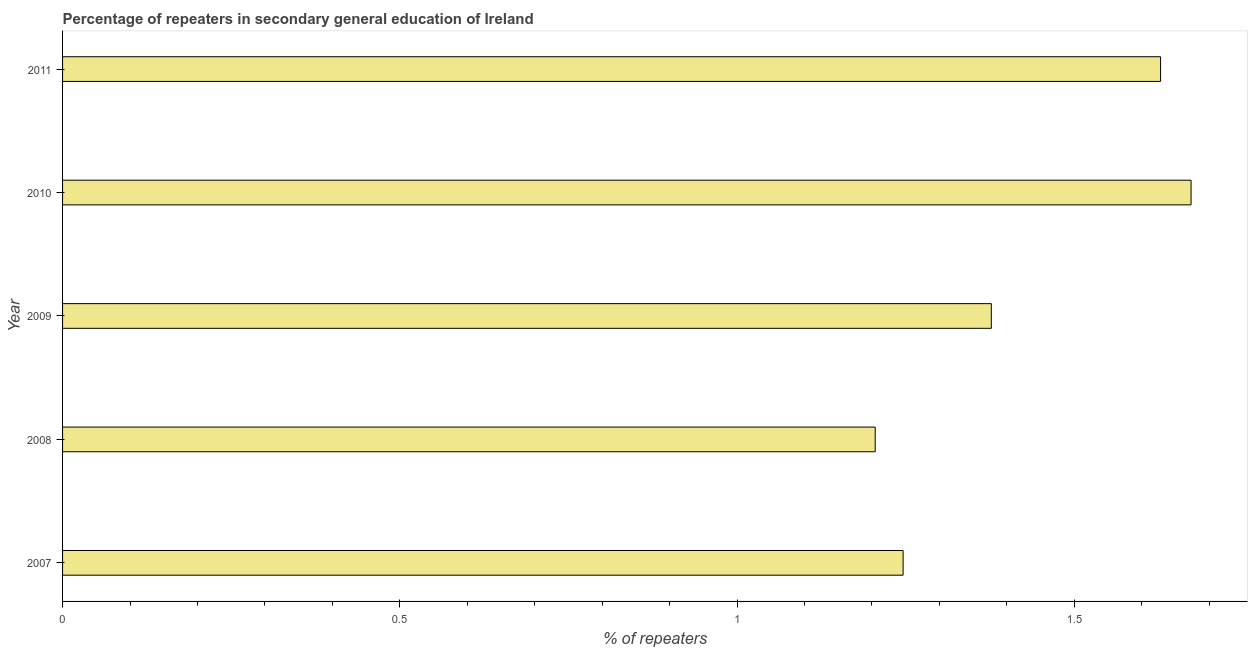What is the title of the graph?
Your answer should be compact. Percentage of repeaters in secondary general education of Ireland. What is the label or title of the X-axis?
Keep it short and to the point. % of repeaters. What is the label or title of the Y-axis?
Give a very brief answer. Year. What is the percentage of repeaters in 2011?
Offer a very short reply. 1.63. Across all years, what is the maximum percentage of repeaters?
Give a very brief answer. 1.67. Across all years, what is the minimum percentage of repeaters?
Your answer should be compact. 1.2. In which year was the percentage of repeaters maximum?
Offer a very short reply. 2010. What is the sum of the percentage of repeaters?
Your response must be concise. 7.13. What is the difference between the percentage of repeaters in 2007 and 2008?
Your response must be concise. 0.04. What is the average percentage of repeaters per year?
Your answer should be very brief. 1.43. What is the median percentage of repeaters?
Your response must be concise. 1.38. What is the ratio of the percentage of repeaters in 2010 to that in 2011?
Give a very brief answer. 1.03. Is the percentage of repeaters in 2010 less than that in 2011?
Your answer should be compact. No. Is the difference between the percentage of repeaters in 2008 and 2010 greater than the difference between any two years?
Give a very brief answer. Yes. What is the difference between the highest and the second highest percentage of repeaters?
Offer a very short reply. 0.04. Is the sum of the percentage of repeaters in 2008 and 2010 greater than the maximum percentage of repeaters across all years?
Your response must be concise. Yes. What is the difference between the highest and the lowest percentage of repeaters?
Your answer should be compact. 0.47. Are all the bars in the graph horizontal?
Your response must be concise. Yes. How many years are there in the graph?
Offer a very short reply. 5. Are the values on the major ticks of X-axis written in scientific E-notation?
Keep it short and to the point. No. What is the % of repeaters in 2007?
Offer a terse response. 1.25. What is the % of repeaters in 2008?
Make the answer very short. 1.2. What is the % of repeaters of 2009?
Your answer should be very brief. 1.38. What is the % of repeaters in 2010?
Your answer should be very brief. 1.67. What is the % of repeaters in 2011?
Offer a very short reply. 1.63. What is the difference between the % of repeaters in 2007 and 2008?
Offer a very short reply. 0.04. What is the difference between the % of repeaters in 2007 and 2009?
Make the answer very short. -0.13. What is the difference between the % of repeaters in 2007 and 2010?
Offer a terse response. -0.43. What is the difference between the % of repeaters in 2007 and 2011?
Make the answer very short. -0.38. What is the difference between the % of repeaters in 2008 and 2009?
Offer a very short reply. -0.17. What is the difference between the % of repeaters in 2008 and 2010?
Your answer should be very brief. -0.47. What is the difference between the % of repeaters in 2008 and 2011?
Ensure brevity in your answer.  -0.42. What is the difference between the % of repeaters in 2009 and 2010?
Keep it short and to the point. -0.3. What is the difference between the % of repeaters in 2009 and 2011?
Keep it short and to the point. -0.25. What is the difference between the % of repeaters in 2010 and 2011?
Offer a very short reply. 0.05. What is the ratio of the % of repeaters in 2007 to that in 2008?
Ensure brevity in your answer.  1.03. What is the ratio of the % of repeaters in 2007 to that in 2009?
Provide a succinct answer. 0.91. What is the ratio of the % of repeaters in 2007 to that in 2010?
Provide a short and direct response. 0.74. What is the ratio of the % of repeaters in 2007 to that in 2011?
Your response must be concise. 0.77. What is the ratio of the % of repeaters in 2008 to that in 2009?
Ensure brevity in your answer.  0.88. What is the ratio of the % of repeaters in 2008 to that in 2010?
Your answer should be very brief. 0.72. What is the ratio of the % of repeaters in 2008 to that in 2011?
Your answer should be very brief. 0.74. What is the ratio of the % of repeaters in 2009 to that in 2010?
Offer a terse response. 0.82. What is the ratio of the % of repeaters in 2009 to that in 2011?
Offer a very short reply. 0.85. What is the ratio of the % of repeaters in 2010 to that in 2011?
Provide a succinct answer. 1.03. 